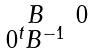Convert formula to latex. <formula><loc_0><loc_0><loc_500><loc_500>\begin{smallmatrix} B & 0 \\ 0 ^ { t } B ^ { - 1 } \end{smallmatrix}</formula> 